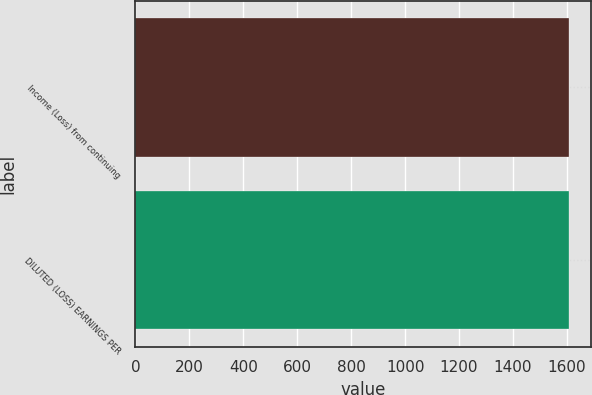Convert chart to OTSL. <chart><loc_0><loc_0><loc_500><loc_500><bar_chart><fcel>Income (Loss) from continuing<fcel>DILUTED (LOSS) EARNINGS PER<nl><fcel>1609<fcel>1609.1<nl></chart> 